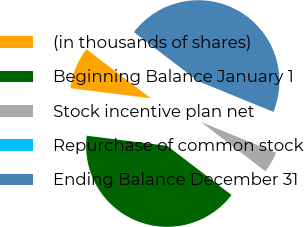Convert chart to OTSL. <chart><loc_0><loc_0><loc_500><loc_500><pie_chart><fcel>(in thousands of shares)<fcel>Beginning Balance January 1<fcel>Stock incentive plan net<fcel>Repurchase of common stock<fcel>Ending Balance December 31<nl><fcel>8.38%<fcel>41.6%<fcel>4.2%<fcel>0.02%<fcel>45.79%<nl></chart> 